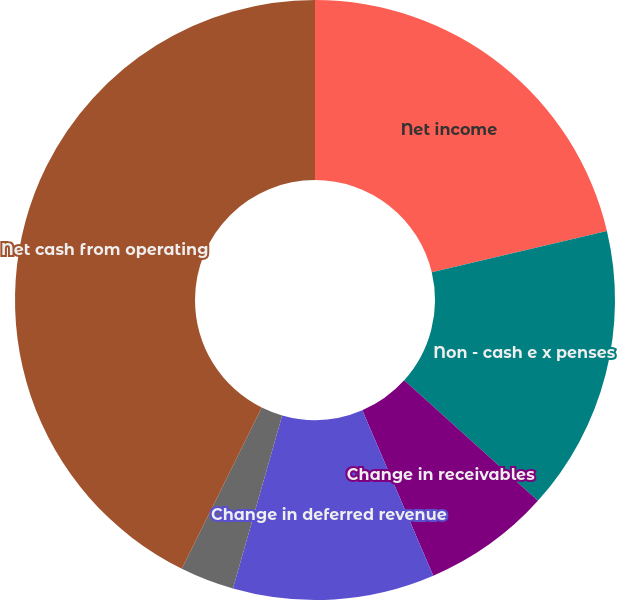Convert chart to OTSL. <chart><loc_0><loc_0><loc_500><loc_500><pie_chart><fcel>Net income<fcel>Non - cash e x penses<fcel>Change in receivables<fcel>Change in deferred revenue<fcel>Change in other assets and<fcel>Net cash from operating<nl><fcel>21.3%<fcel>15.37%<fcel>6.88%<fcel>10.86%<fcel>2.91%<fcel>42.68%<nl></chart> 